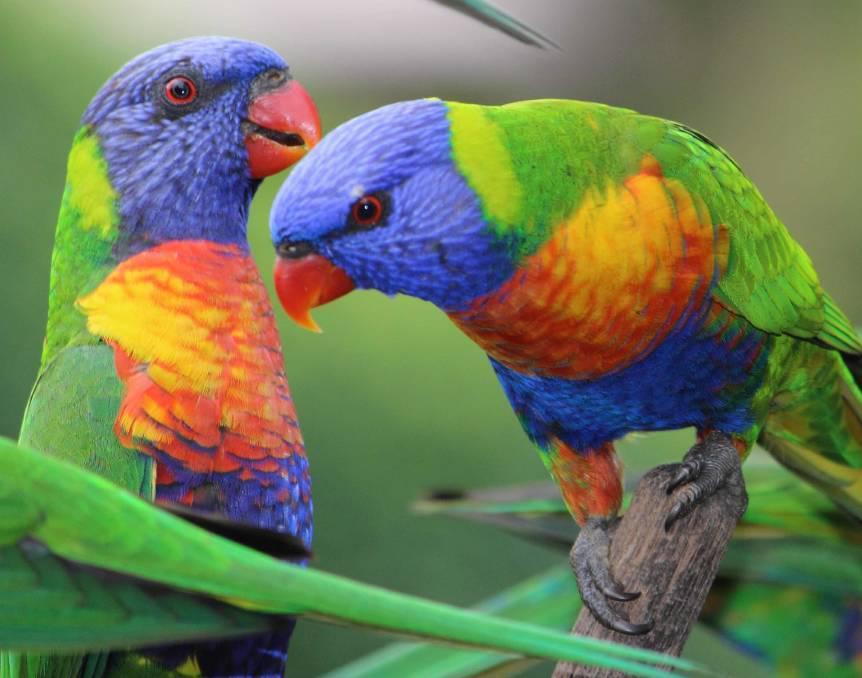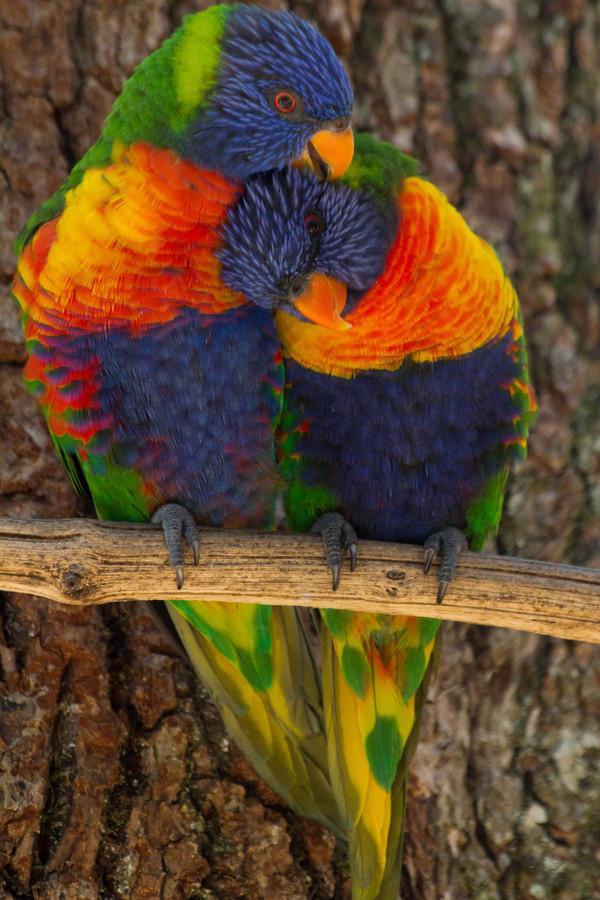The first image is the image on the left, the second image is the image on the right. Given the left and right images, does the statement "All of the images contain at least two parrots." hold true? Answer yes or no. Yes. 